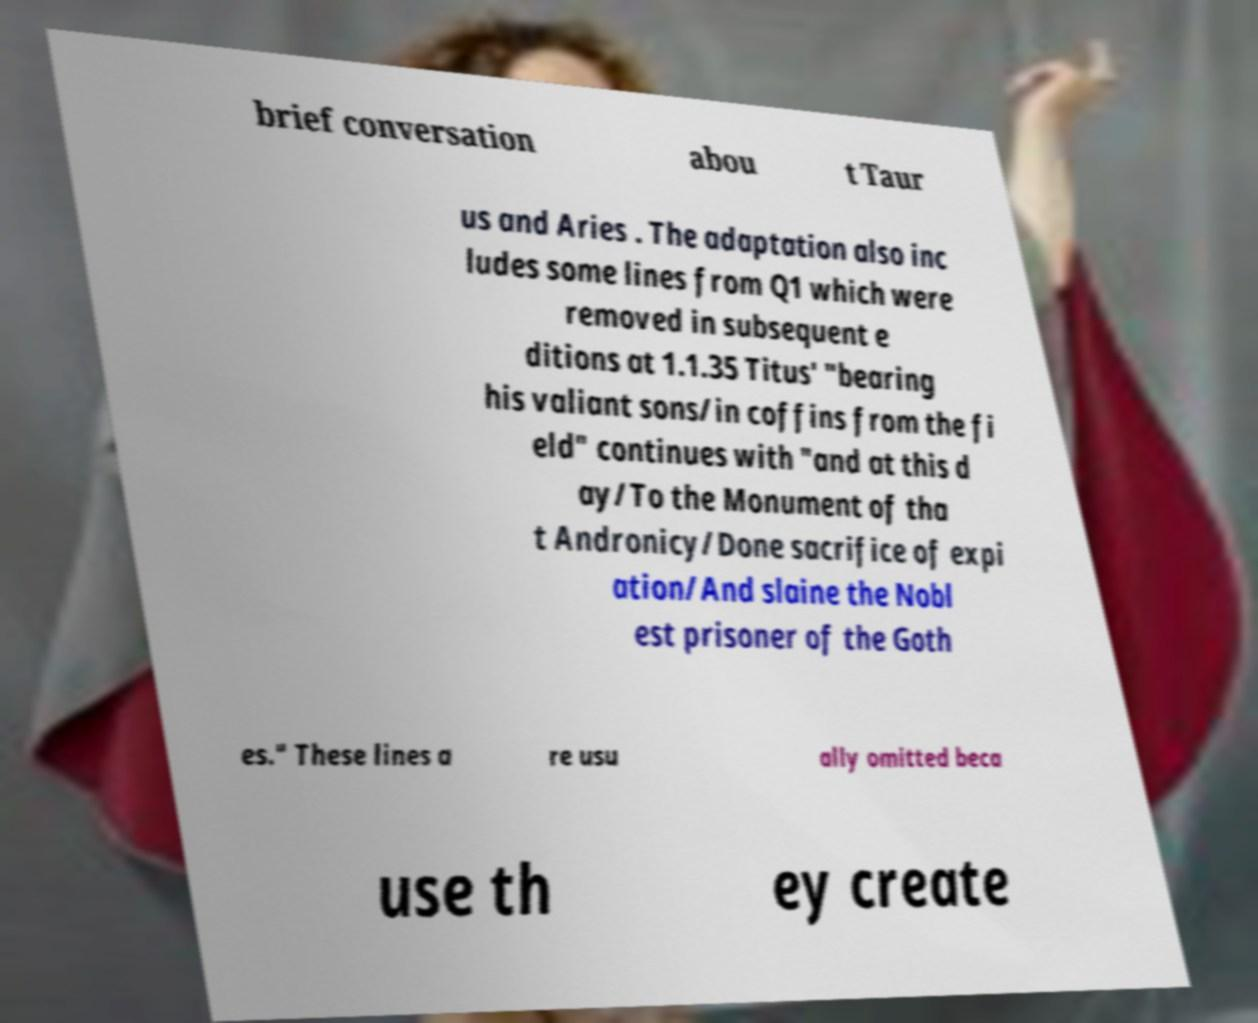Please identify and transcribe the text found in this image. brief conversation abou t Taur us and Aries . The adaptation also inc ludes some lines from Q1 which were removed in subsequent e ditions at 1.1.35 Titus' "bearing his valiant sons/in coffins from the fi eld" continues with "and at this d ay/To the Monument of tha t Andronicy/Done sacrifice of expi ation/And slaine the Nobl est prisoner of the Goth es." These lines a re usu ally omitted beca use th ey create 